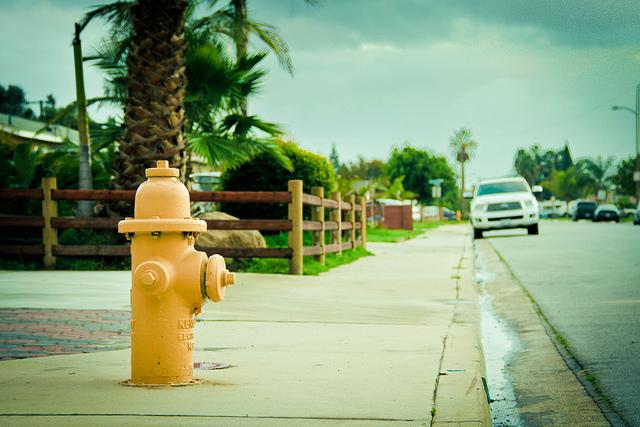What kind of weather is one likely to experience in this area?

Choices:
A) tropical
B) arid
C) rainy
D) cold tropical 